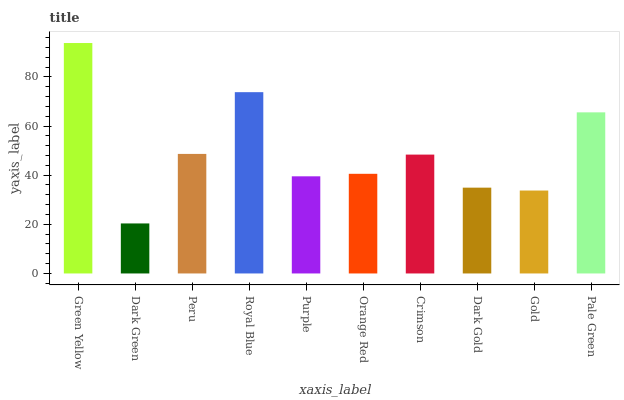Is Dark Green the minimum?
Answer yes or no. Yes. Is Green Yellow the maximum?
Answer yes or no. Yes. Is Peru the minimum?
Answer yes or no. No. Is Peru the maximum?
Answer yes or no. No. Is Peru greater than Dark Green?
Answer yes or no. Yes. Is Dark Green less than Peru?
Answer yes or no. Yes. Is Dark Green greater than Peru?
Answer yes or no. No. Is Peru less than Dark Green?
Answer yes or no. No. Is Crimson the high median?
Answer yes or no. Yes. Is Orange Red the low median?
Answer yes or no. Yes. Is Peru the high median?
Answer yes or no. No. Is Green Yellow the low median?
Answer yes or no. No. 